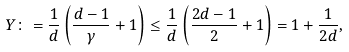Convert formula to latex. <formula><loc_0><loc_0><loc_500><loc_500>Y \colon = \frac { 1 } { d } \left ( \frac { d - 1 } { \gamma } + 1 \right ) \leq \frac { 1 } { d } \left ( \frac { 2 d - 1 } { 2 } + 1 \right ) = 1 + \frac { 1 } { 2 d } ,</formula> 